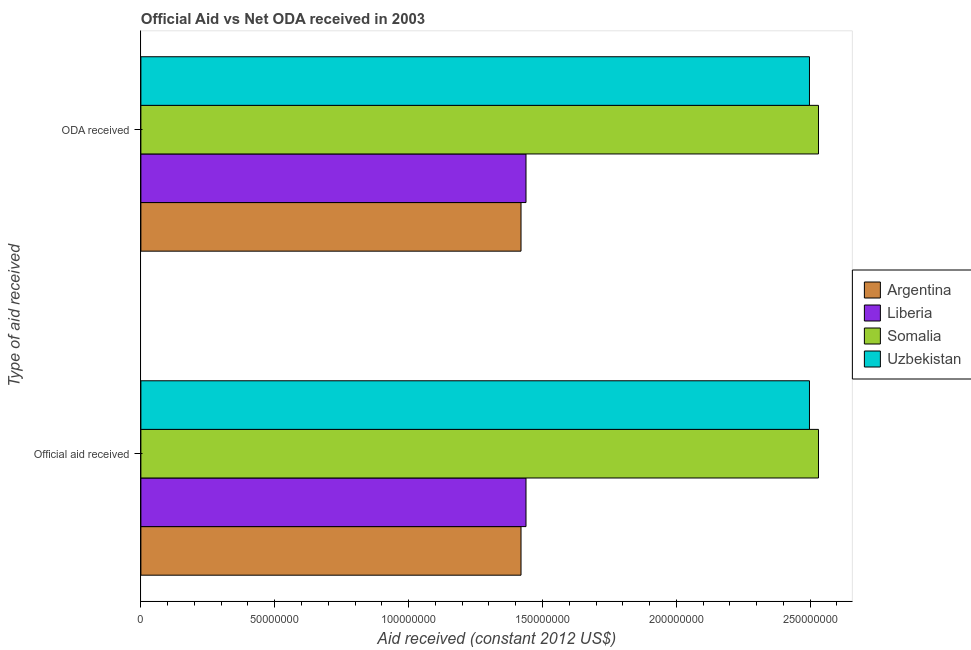How many different coloured bars are there?
Give a very brief answer. 4. How many groups of bars are there?
Offer a terse response. 2. How many bars are there on the 1st tick from the top?
Provide a short and direct response. 4. How many bars are there on the 2nd tick from the bottom?
Keep it short and to the point. 4. What is the label of the 1st group of bars from the top?
Your response must be concise. ODA received. What is the official aid received in Somalia?
Offer a very short reply. 2.53e+08. Across all countries, what is the maximum official aid received?
Your answer should be compact. 2.53e+08. Across all countries, what is the minimum oda received?
Give a very brief answer. 1.42e+08. In which country was the oda received maximum?
Make the answer very short. Somalia. In which country was the oda received minimum?
Give a very brief answer. Argentina. What is the total official aid received in the graph?
Provide a succinct answer. 7.89e+08. What is the difference between the official aid received in Argentina and that in Somalia?
Your response must be concise. -1.11e+08. What is the difference between the official aid received in Somalia and the oda received in Liberia?
Your answer should be compact. 1.09e+08. What is the average oda received per country?
Provide a short and direct response. 1.97e+08. In how many countries, is the oda received greater than 120000000 US$?
Make the answer very short. 4. What is the ratio of the official aid received in Uzbekistan to that in Argentina?
Provide a short and direct response. 1.76. In how many countries, is the oda received greater than the average oda received taken over all countries?
Ensure brevity in your answer.  2. What does the 1st bar from the bottom in Official aid received represents?
Offer a very short reply. Argentina. How many bars are there?
Ensure brevity in your answer.  8. Are all the bars in the graph horizontal?
Your response must be concise. Yes. How many countries are there in the graph?
Give a very brief answer. 4. What is the difference between two consecutive major ticks on the X-axis?
Offer a very short reply. 5.00e+07. Are the values on the major ticks of X-axis written in scientific E-notation?
Provide a short and direct response. No. Does the graph contain any zero values?
Provide a short and direct response. No. Does the graph contain grids?
Provide a succinct answer. No. How many legend labels are there?
Give a very brief answer. 4. How are the legend labels stacked?
Provide a short and direct response. Vertical. What is the title of the graph?
Your answer should be compact. Official Aid vs Net ODA received in 2003 . What is the label or title of the X-axis?
Offer a terse response. Aid received (constant 2012 US$). What is the label or title of the Y-axis?
Offer a very short reply. Type of aid received. What is the Aid received (constant 2012 US$) in Argentina in Official aid received?
Your answer should be compact. 1.42e+08. What is the Aid received (constant 2012 US$) of Liberia in Official aid received?
Provide a succinct answer. 1.44e+08. What is the Aid received (constant 2012 US$) of Somalia in Official aid received?
Give a very brief answer. 2.53e+08. What is the Aid received (constant 2012 US$) of Uzbekistan in Official aid received?
Ensure brevity in your answer.  2.50e+08. What is the Aid received (constant 2012 US$) of Argentina in ODA received?
Your answer should be very brief. 1.42e+08. What is the Aid received (constant 2012 US$) in Liberia in ODA received?
Provide a succinct answer. 1.44e+08. What is the Aid received (constant 2012 US$) of Somalia in ODA received?
Your answer should be compact. 2.53e+08. What is the Aid received (constant 2012 US$) in Uzbekistan in ODA received?
Ensure brevity in your answer.  2.50e+08. Across all Type of aid received, what is the maximum Aid received (constant 2012 US$) of Argentina?
Your answer should be compact. 1.42e+08. Across all Type of aid received, what is the maximum Aid received (constant 2012 US$) in Liberia?
Keep it short and to the point. 1.44e+08. Across all Type of aid received, what is the maximum Aid received (constant 2012 US$) in Somalia?
Give a very brief answer. 2.53e+08. Across all Type of aid received, what is the maximum Aid received (constant 2012 US$) of Uzbekistan?
Your answer should be very brief. 2.50e+08. Across all Type of aid received, what is the minimum Aid received (constant 2012 US$) of Argentina?
Your answer should be compact. 1.42e+08. Across all Type of aid received, what is the minimum Aid received (constant 2012 US$) of Liberia?
Your answer should be very brief. 1.44e+08. Across all Type of aid received, what is the minimum Aid received (constant 2012 US$) in Somalia?
Keep it short and to the point. 2.53e+08. Across all Type of aid received, what is the minimum Aid received (constant 2012 US$) in Uzbekistan?
Ensure brevity in your answer.  2.50e+08. What is the total Aid received (constant 2012 US$) of Argentina in the graph?
Provide a short and direct response. 2.84e+08. What is the total Aid received (constant 2012 US$) in Liberia in the graph?
Provide a succinct answer. 2.88e+08. What is the total Aid received (constant 2012 US$) of Somalia in the graph?
Your answer should be very brief. 5.06e+08. What is the total Aid received (constant 2012 US$) of Uzbekistan in the graph?
Keep it short and to the point. 4.99e+08. What is the difference between the Aid received (constant 2012 US$) in Liberia in Official aid received and that in ODA received?
Offer a terse response. 0. What is the difference between the Aid received (constant 2012 US$) in Somalia in Official aid received and that in ODA received?
Give a very brief answer. 0. What is the difference between the Aid received (constant 2012 US$) of Uzbekistan in Official aid received and that in ODA received?
Give a very brief answer. 0. What is the difference between the Aid received (constant 2012 US$) of Argentina in Official aid received and the Aid received (constant 2012 US$) of Liberia in ODA received?
Provide a short and direct response. -1.86e+06. What is the difference between the Aid received (constant 2012 US$) in Argentina in Official aid received and the Aid received (constant 2012 US$) in Somalia in ODA received?
Provide a succinct answer. -1.11e+08. What is the difference between the Aid received (constant 2012 US$) in Argentina in Official aid received and the Aid received (constant 2012 US$) in Uzbekistan in ODA received?
Provide a short and direct response. -1.08e+08. What is the difference between the Aid received (constant 2012 US$) of Liberia in Official aid received and the Aid received (constant 2012 US$) of Somalia in ODA received?
Make the answer very short. -1.09e+08. What is the difference between the Aid received (constant 2012 US$) of Liberia in Official aid received and the Aid received (constant 2012 US$) of Uzbekistan in ODA received?
Make the answer very short. -1.06e+08. What is the difference between the Aid received (constant 2012 US$) in Somalia in Official aid received and the Aid received (constant 2012 US$) in Uzbekistan in ODA received?
Keep it short and to the point. 3.37e+06. What is the average Aid received (constant 2012 US$) in Argentina per Type of aid received?
Offer a very short reply. 1.42e+08. What is the average Aid received (constant 2012 US$) of Liberia per Type of aid received?
Ensure brevity in your answer.  1.44e+08. What is the average Aid received (constant 2012 US$) in Somalia per Type of aid received?
Ensure brevity in your answer.  2.53e+08. What is the average Aid received (constant 2012 US$) of Uzbekistan per Type of aid received?
Provide a succinct answer. 2.50e+08. What is the difference between the Aid received (constant 2012 US$) of Argentina and Aid received (constant 2012 US$) of Liberia in Official aid received?
Make the answer very short. -1.86e+06. What is the difference between the Aid received (constant 2012 US$) of Argentina and Aid received (constant 2012 US$) of Somalia in Official aid received?
Offer a terse response. -1.11e+08. What is the difference between the Aid received (constant 2012 US$) in Argentina and Aid received (constant 2012 US$) in Uzbekistan in Official aid received?
Ensure brevity in your answer.  -1.08e+08. What is the difference between the Aid received (constant 2012 US$) of Liberia and Aid received (constant 2012 US$) of Somalia in Official aid received?
Your response must be concise. -1.09e+08. What is the difference between the Aid received (constant 2012 US$) of Liberia and Aid received (constant 2012 US$) of Uzbekistan in Official aid received?
Offer a terse response. -1.06e+08. What is the difference between the Aid received (constant 2012 US$) of Somalia and Aid received (constant 2012 US$) of Uzbekistan in Official aid received?
Provide a short and direct response. 3.37e+06. What is the difference between the Aid received (constant 2012 US$) in Argentina and Aid received (constant 2012 US$) in Liberia in ODA received?
Ensure brevity in your answer.  -1.86e+06. What is the difference between the Aid received (constant 2012 US$) of Argentina and Aid received (constant 2012 US$) of Somalia in ODA received?
Your answer should be very brief. -1.11e+08. What is the difference between the Aid received (constant 2012 US$) in Argentina and Aid received (constant 2012 US$) in Uzbekistan in ODA received?
Offer a very short reply. -1.08e+08. What is the difference between the Aid received (constant 2012 US$) in Liberia and Aid received (constant 2012 US$) in Somalia in ODA received?
Your response must be concise. -1.09e+08. What is the difference between the Aid received (constant 2012 US$) of Liberia and Aid received (constant 2012 US$) of Uzbekistan in ODA received?
Make the answer very short. -1.06e+08. What is the difference between the Aid received (constant 2012 US$) in Somalia and Aid received (constant 2012 US$) in Uzbekistan in ODA received?
Give a very brief answer. 3.37e+06. What is the ratio of the Aid received (constant 2012 US$) in Uzbekistan in Official aid received to that in ODA received?
Offer a very short reply. 1. What is the difference between the highest and the lowest Aid received (constant 2012 US$) of Uzbekistan?
Your response must be concise. 0. 